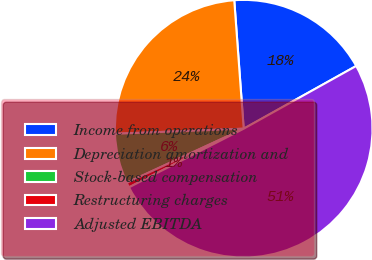Convert chart. <chart><loc_0><loc_0><loc_500><loc_500><pie_chart><fcel>Income from operations<fcel>Depreciation amortization and<fcel>Stock-based compensation<fcel>Restructuring charges<fcel>Adjusted EBITDA<nl><fcel>18.07%<fcel>24.46%<fcel>6.26%<fcel>0.63%<fcel>50.57%<nl></chart> 